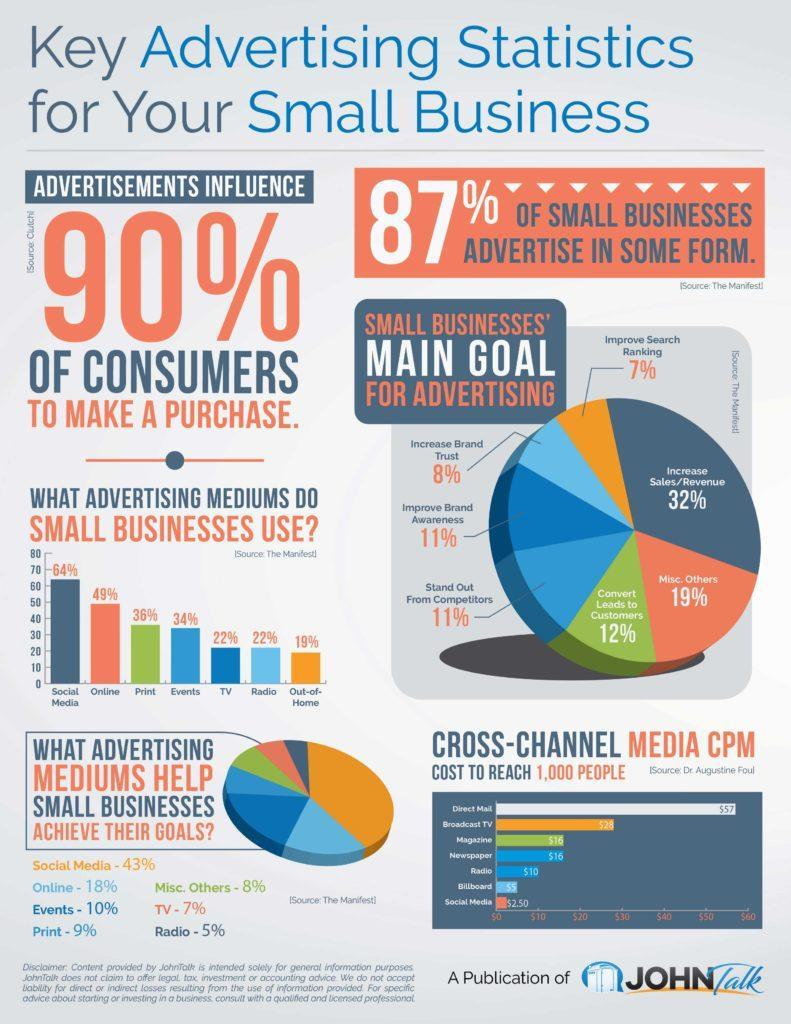What percentage can TV advertising help small businesses to achieve their goals?
Answer the question with a short phrase. 7% What percentage increase in sales is expected to be achieved by small businesses through advertising? 32% What percentage of the small businesses use online advertising? 49% What percentage of the small businesses use radio advertising? 22% Which advertising medium is widely used by most of the small businesses? Social Media What percentage increase in brand trust is expected to be achieved by small businesses through advertising? 8% What percentage can social media advertising help small businesses to achieve their goals? 43% 